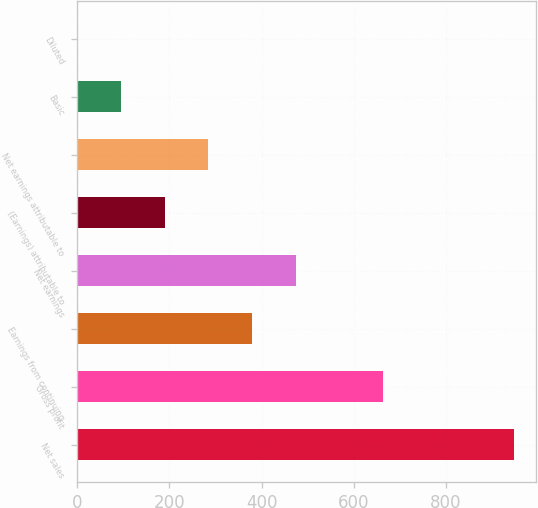Convert chart to OTSL. <chart><loc_0><loc_0><loc_500><loc_500><bar_chart><fcel>Net sales<fcel>Gross profit<fcel>Earnings from continuing<fcel>Net earnings<fcel>(Earnings) attributable to<fcel>Net earnings attributable to<fcel>Basic<fcel>Diluted<nl><fcel>946.8<fcel>662.85<fcel>378.9<fcel>473.55<fcel>189.6<fcel>284.25<fcel>94.95<fcel>0.3<nl></chart> 